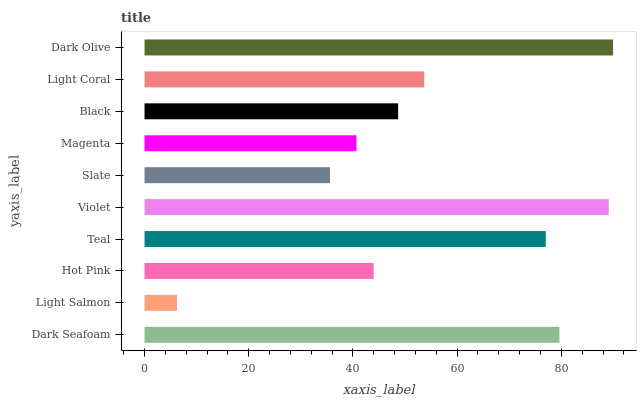Is Light Salmon the minimum?
Answer yes or no. Yes. Is Dark Olive the maximum?
Answer yes or no. Yes. Is Hot Pink the minimum?
Answer yes or no. No. Is Hot Pink the maximum?
Answer yes or no. No. Is Hot Pink greater than Light Salmon?
Answer yes or no. Yes. Is Light Salmon less than Hot Pink?
Answer yes or no. Yes. Is Light Salmon greater than Hot Pink?
Answer yes or no. No. Is Hot Pink less than Light Salmon?
Answer yes or no. No. Is Light Coral the high median?
Answer yes or no. Yes. Is Black the low median?
Answer yes or no. Yes. Is Slate the high median?
Answer yes or no. No. Is Slate the low median?
Answer yes or no. No. 